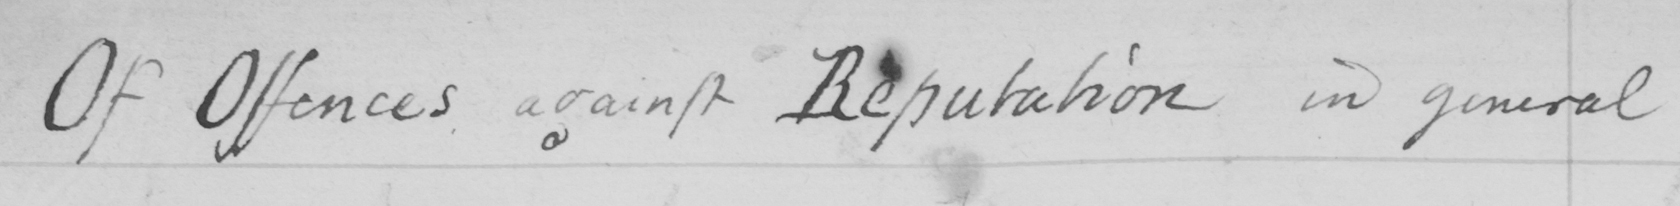What text is written in this handwritten line? Of Offences against Reputation in general 